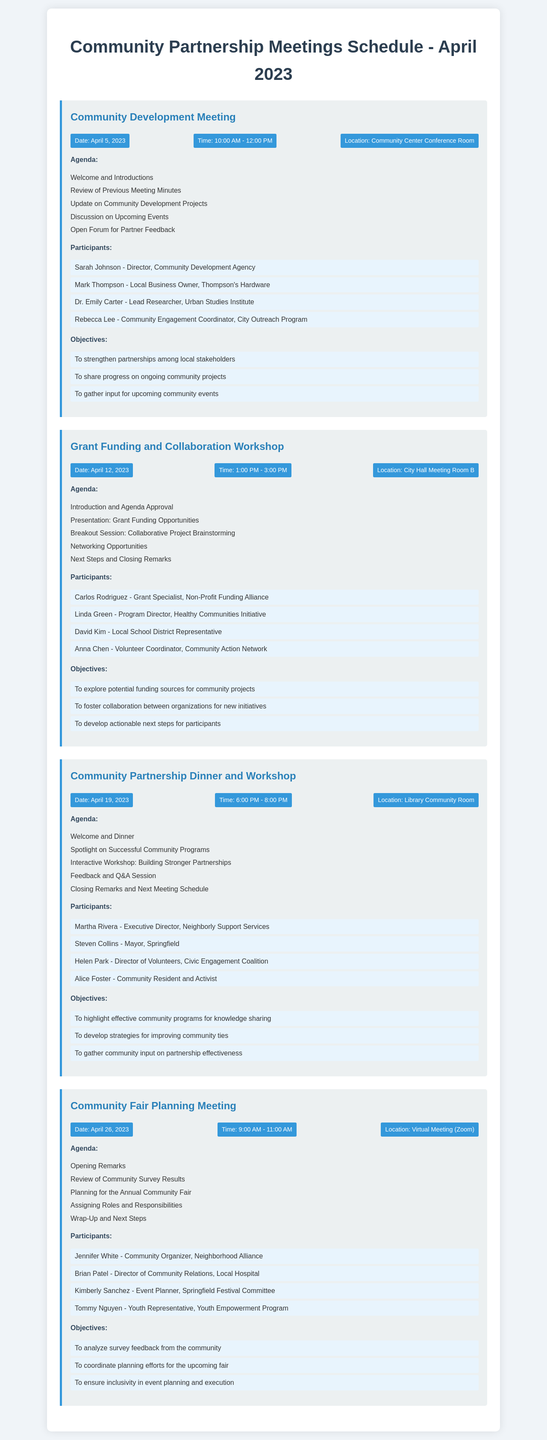What is the date of the Community Development Meeting? The date is found in the meeting details for the Community Development Meeting.
Answer: April 5, 2023 Who is the Program Director for the Healthy Communities Initiative? This information can be found in the participants list for the Grant Funding and Collaboration Workshop.
Answer: Linda Green What time does the Community Partnership Dinner and Workshop start? The start time is indicated in the meeting info for the Community Partnership Dinner and Workshop.
Answer: 6:00 PM What is one of the objectives of the Community Fair Planning Meeting? The objectives are listed and provide insight into the goals of the meeting.
Answer: To analyze survey feedback from the community Which participant represents the Youth Empowerment Program? This information is found in the list of participants for the Community Fair Planning Meeting.
Answer: Tommy Nguyen What is the main focus of the Grant Funding and Collaboration Workshop? The primary focus is stated in the objectives section of the workshop.
Answer: To explore potential funding sources for community projects How many participants are listed for the Community Development Meeting? This requires counting the participants listed in that specific meeting.
Answer: Four Where is the Community Partnership Dinner and Workshop held? The location is provided in the meeting details for that particular event.
Answer: Library Community Room 